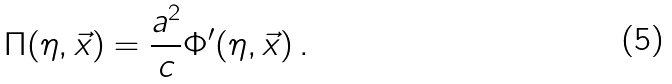<formula> <loc_0><loc_0><loc_500><loc_500>\Pi ( \eta , \vec { x } ) = \frac { a ^ { 2 } } { c } \Phi ^ { \prime } ( \eta , \vec { x } ) \, .</formula> 